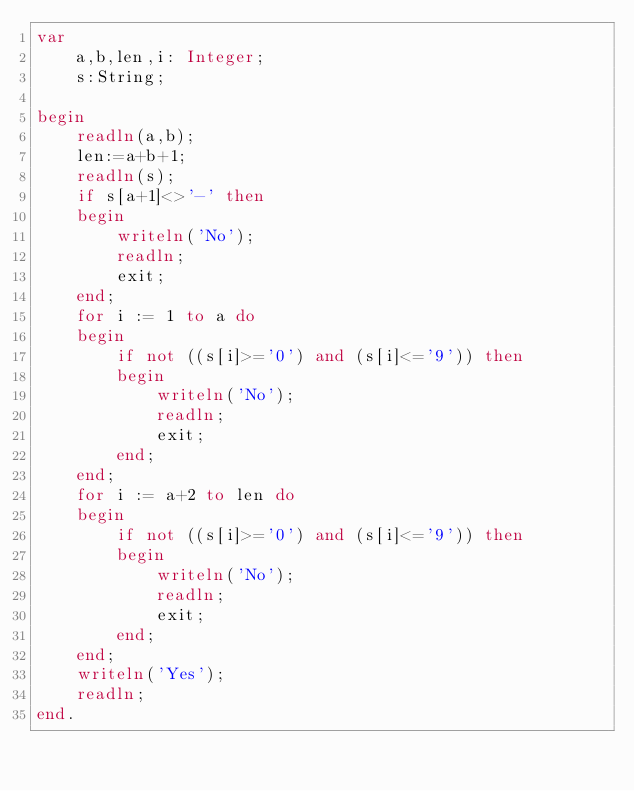<code> <loc_0><loc_0><loc_500><loc_500><_Pascal_>var
    a,b,len,i: Integer;
    s:String;

begin
    readln(a,b);
    len:=a+b+1;
    readln(s);
    if s[a+1]<>'-' then
    begin
        writeln('No');
        readln;
        exit;
    end;
    for i := 1 to a do
    begin
        if not ((s[i]>='0') and (s[i]<='9')) then
        begin
            writeln('No');
            readln;
            exit;
        end;
    end; 
    for i := a+2 to len do 
    begin
        if not ((s[i]>='0') and (s[i]<='9')) then
        begin
            writeln('No');
            readln;
            exit;
        end;
    end;
    writeln('Yes');
    readln;
end.</code> 